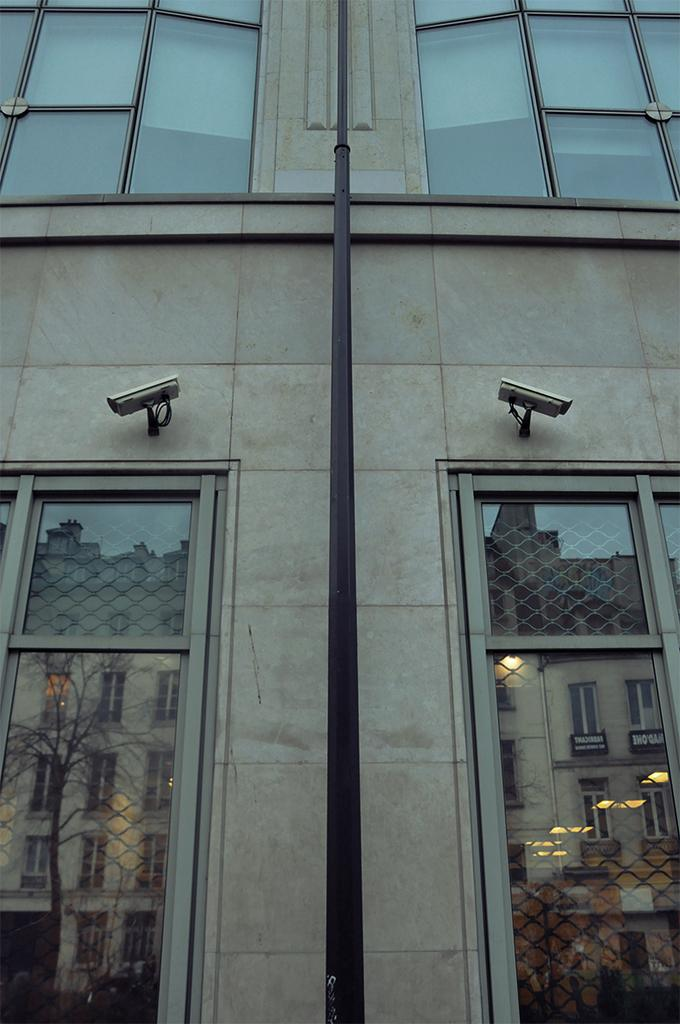What type of structure can be seen in the image? There is a wall in the image. What security feature is present in the image? There are CCTV cameras in the image. What type of windows are visible in the image? There are glass windows in the image. What can be seen reflected in the glass windows? The reflection of a building is visible in the glass windows. What color is the pole in the image? The pole in the image is black-colored. Can you see any veins in the image? There are no veins visible in the image; it features a wall, CCTV cameras, glass windows, a building's reflection, and a black-colored pole. Is there a mailbox present in the image? There is no mailbox visible in the image. 